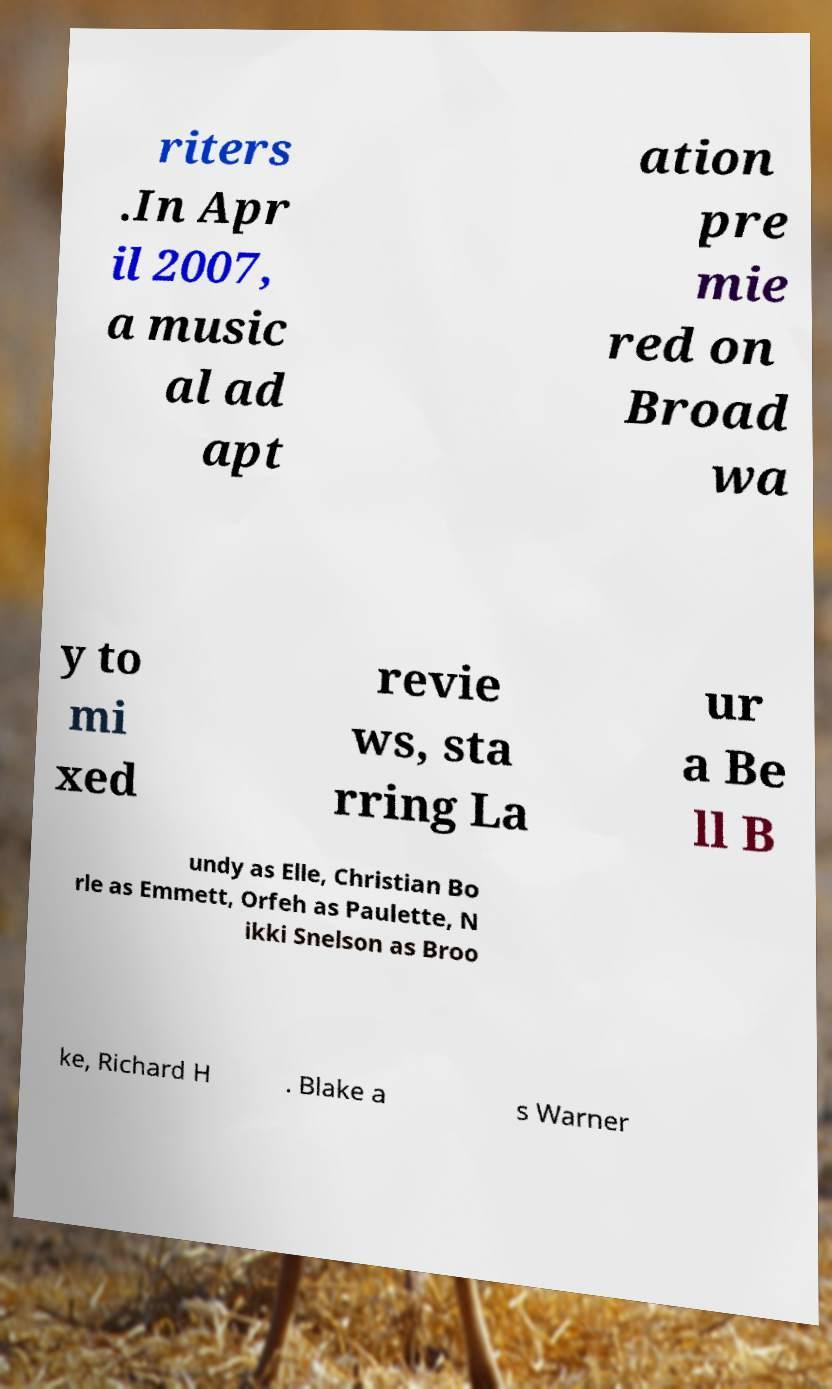Please read and relay the text visible in this image. What does it say? riters .In Apr il 2007, a music al ad apt ation pre mie red on Broad wa y to mi xed revie ws, sta rring La ur a Be ll B undy as Elle, Christian Bo rle as Emmett, Orfeh as Paulette, N ikki Snelson as Broo ke, Richard H . Blake a s Warner 